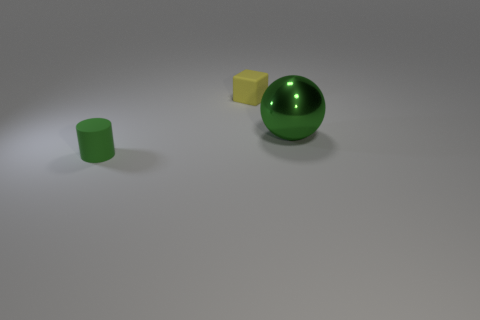Is there anything else that has the same material as the large thing?
Offer a very short reply. No. What size is the other thing that is the same color as the metal object?
Offer a very short reply. Small. Is the number of green metal spheres that are on the left side of the big object less than the number of yellow blocks?
Your response must be concise. Yes. There is another object that is the same color as the big metallic object; what shape is it?
Keep it short and to the point. Cylinder. What number of rubber blocks have the same size as the green ball?
Offer a very short reply. 0. What is the shape of the tiny matte object that is left of the small cube?
Offer a very short reply. Cylinder. Is the number of yellow matte cylinders less than the number of big green things?
Provide a succinct answer. Yes. Is there any other thing that has the same color as the cylinder?
Your response must be concise. Yes. There is a green thing right of the yellow block; how big is it?
Offer a terse response. Large. Are there more brown metal objects than tiny cylinders?
Provide a short and direct response. No. 